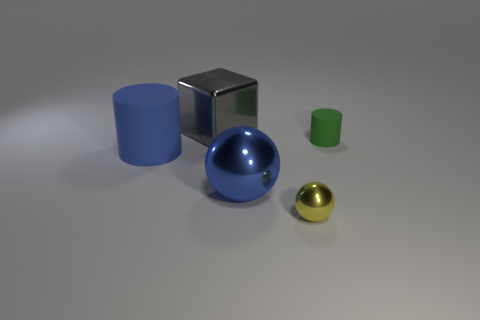Is there any object that stands out due to its texture or reflective surface? The silver cube in the center immediately stands out due to its highly reflective surface. It contrasts with the matte texture of the other objects, reflecting the environment and providing a mirror-like appearance. 